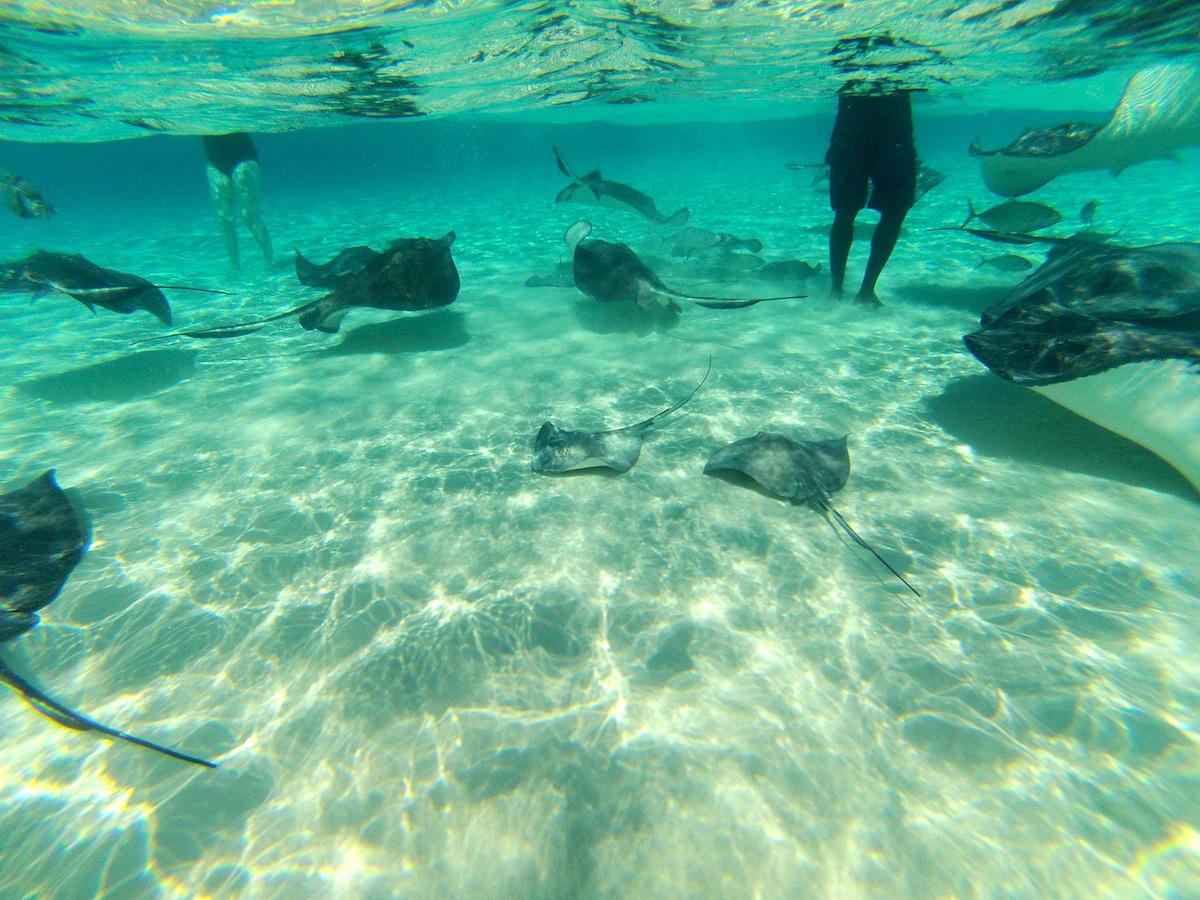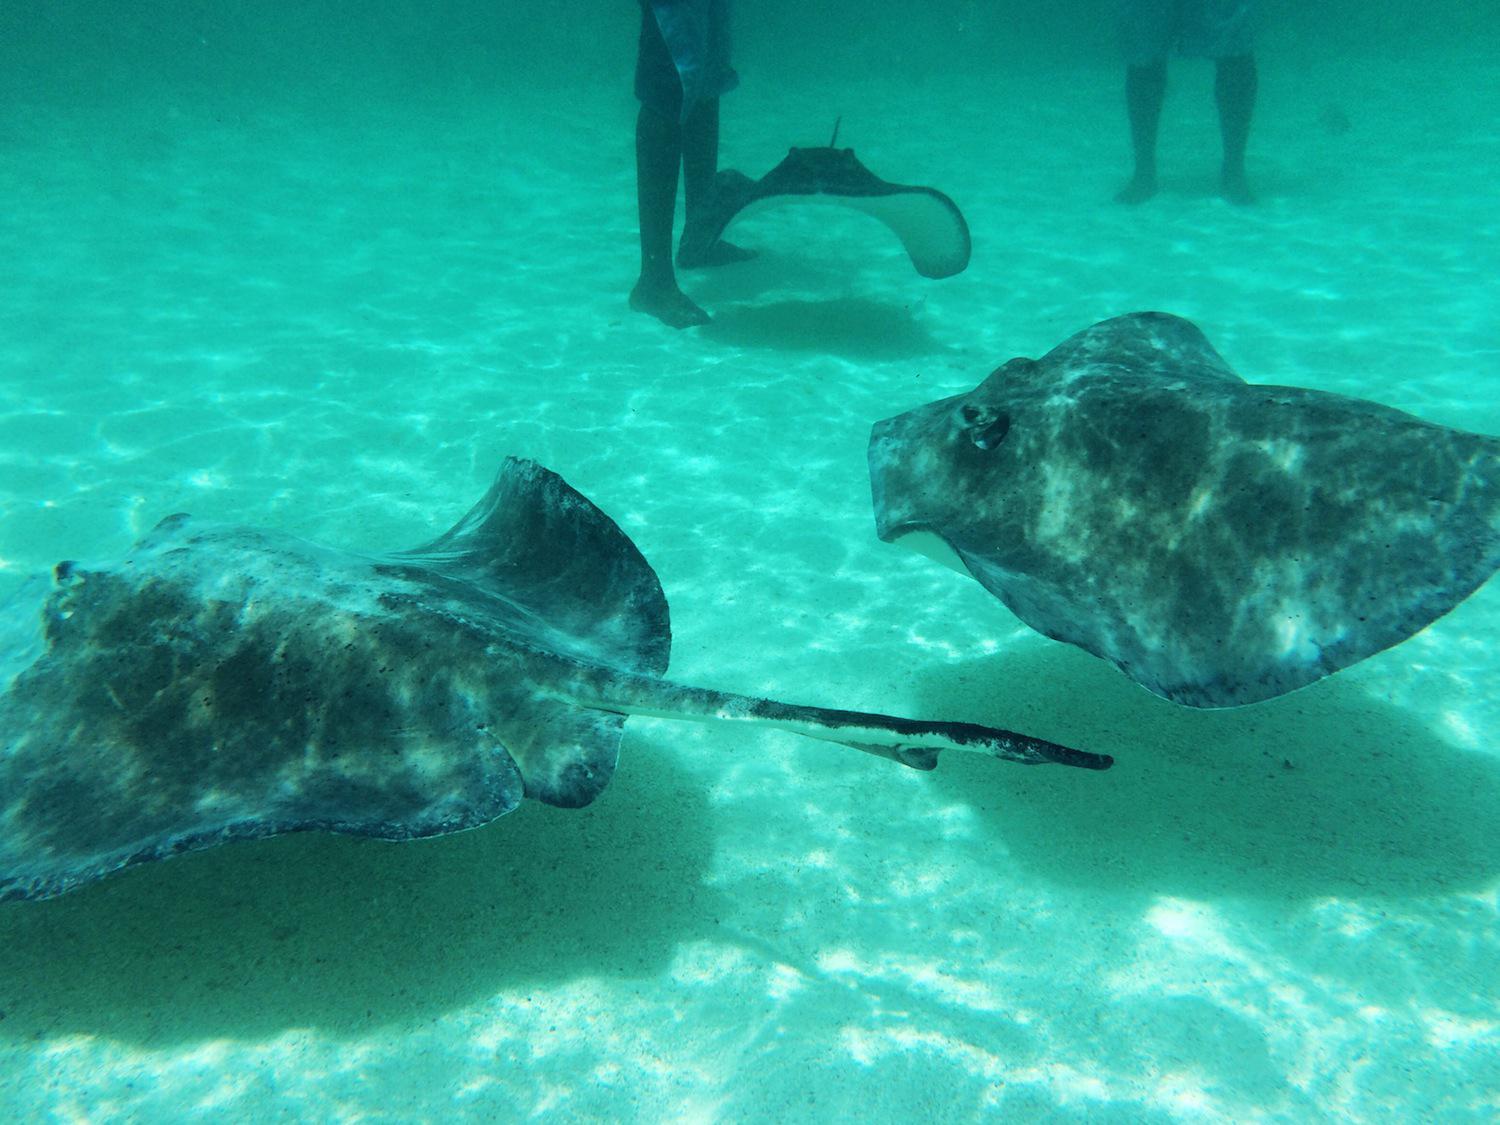The first image is the image on the left, the second image is the image on the right. Examine the images to the left and right. Is the description "Each image contains people in a body of water with rays in it." accurate? Answer yes or no. Yes. The first image is the image on the left, the second image is the image on the right. For the images displayed, is the sentence "There is at least one human in the ocean in the left image." factually correct? Answer yes or no. Yes. 